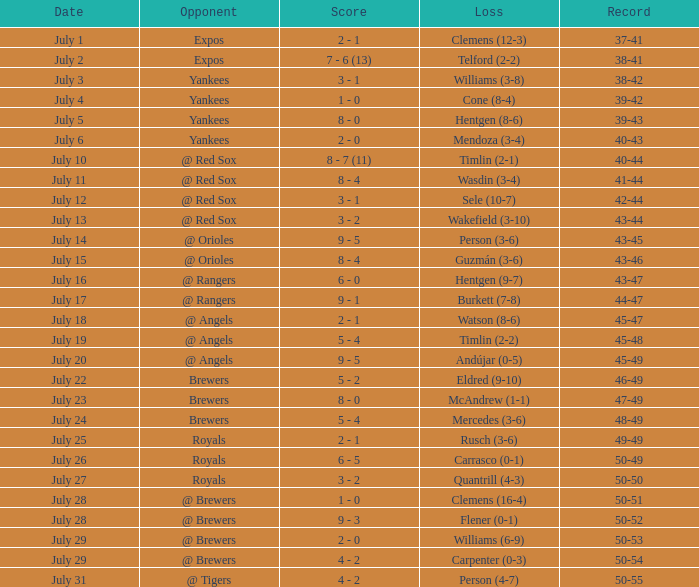What's the record on july 10? 40-44. 